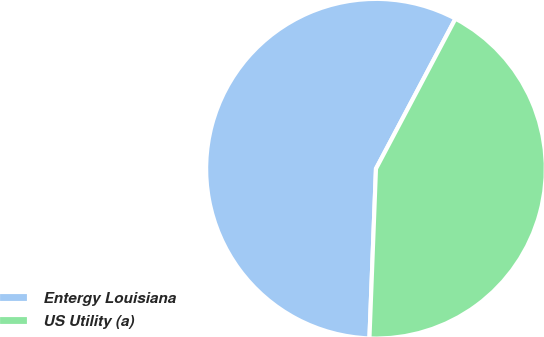Convert chart. <chart><loc_0><loc_0><loc_500><loc_500><pie_chart><fcel>Entergy Louisiana<fcel>US Utility (a)<nl><fcel>57.14%<fcel>42.86%<nl></chart> 